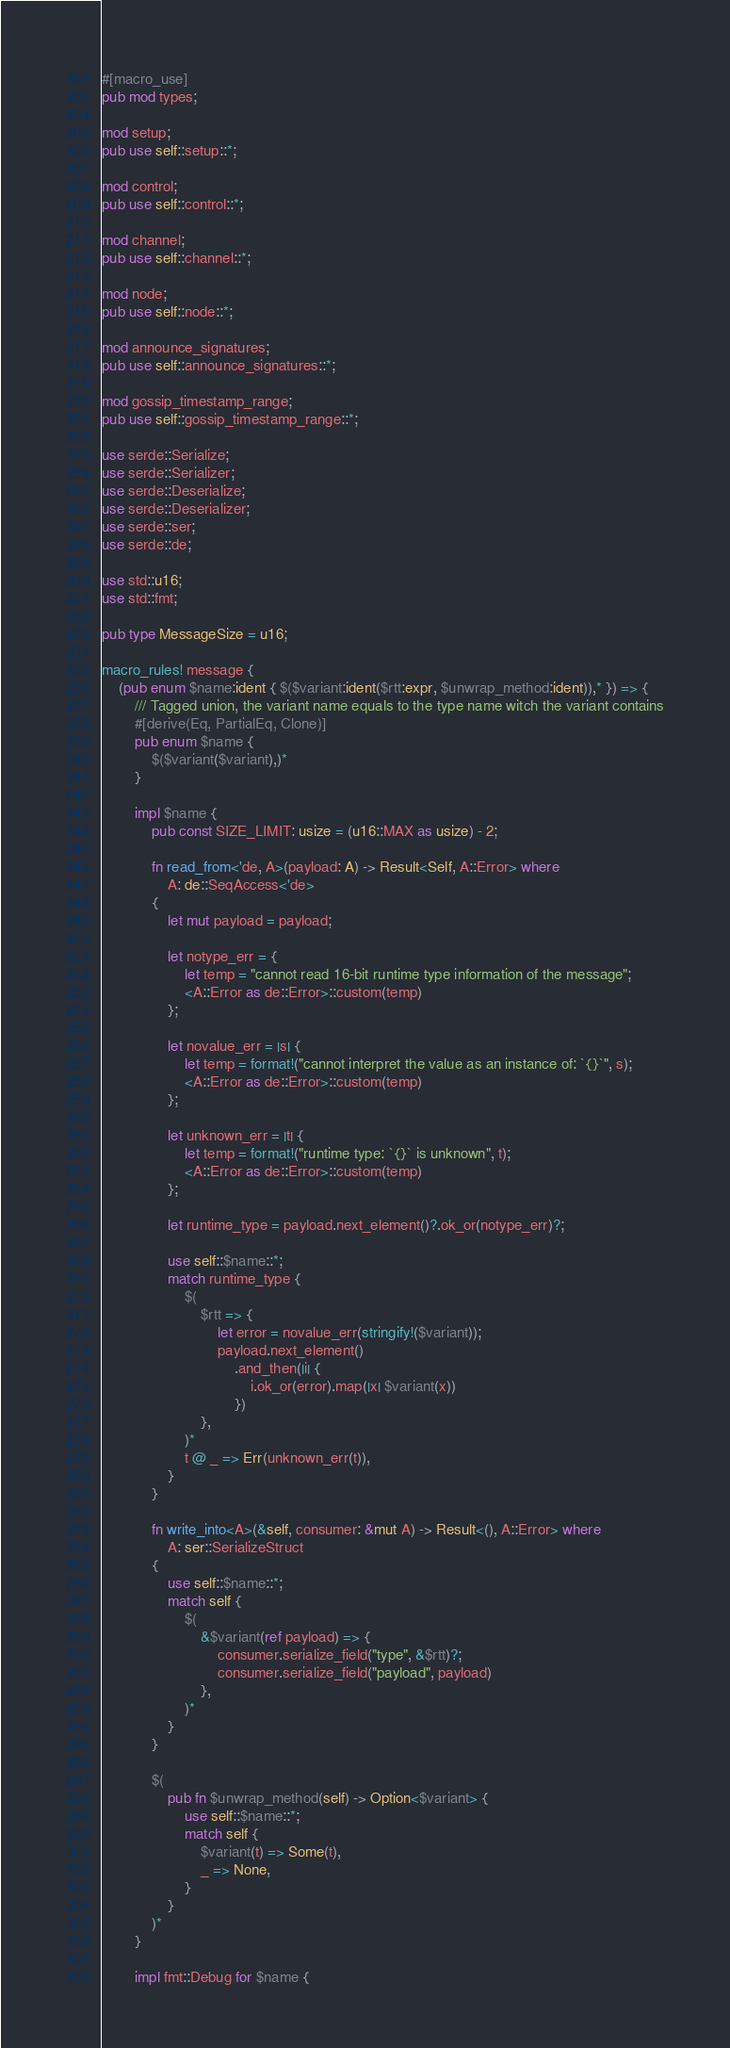<code> <loc_0><loc_0><loc_500><loc_500><_Rust_>#[macro_use]
pub mod types;

mod setup;
pub use self::setup::*;

mod control;
pub use self::control::*;

mod channel;
pub use self::channel::*;

mod node;
pub use self::node::*;

mod announce_signatures;
pub use self::announce_signatures::*;

mod gossip_timestamp_range;
pub use self::gossip_timestamp_range::*;

use serde::Serialize;
use serde::Serializer;
use serde::Deserialize;
use serde::Deserializer;
use serde::ser;
use serde::de;

use std::u16;
use std::fmt;

pub type MessageSize = u16;

macro_rules! message {
    (pub enum $name:ident { $($variant:ident($rtt:expr, $unwrap_method:ident)),* }) => {
        /// Tagged union, the variant name equals to the type name witch the variant contains
        #[derive(Eq, PartialEq, Clone)]
        pub enum $name {
            $($variant($variant),)*
        }

        impl $name {
            pub const SIZE_LIMIT: usize = (u16::MAX as usize) - 2;

            fn read_from<'de, A>(payload: A) -> Result<Self, A::Error> where
                A: de::SeqAccess<'de>
            {
                let mut payload = payload;

                let notype_err = {
                    let temp = "cannot read 16-bit runtime type information of the message";
                    <A::Error as de::Error>::custom(temp)
                };

                let novalue_err = |s| {
                    let temp = format!("cannot interpret the value as an instance of: `{}`", s);
                    <A::Error as de::Error>::custom(temp)
                };

                let unknown_err = |t| {
                    let temp = format!("runtime type: `{}` is unknown", t);
                    <A::Error as de::Error>::custom(temp)
                };

                let runtime_type = payload.next_element()?.ok_or(notype_err)?;

                use self::$name::*;
                match runtime_type {
                    $(
                        $rtt => {
                            let error = novalue_err(stringify!($variant));
                            payload.next_element()
                                .and_then(|i| {
                                    i.ok_or(error).map(|x| $variant(x))
                                })
                        },
                    )*
                    t @ _ => Err(unknown_err(t)),
                }
            }

            fn write_into<A>(&self, consumer: &mut A) -> Result<(), A::Error> where
                A: ser::SerializeStruct
            {
                use self::$name::*;
                match self {
                    $(
                        &$variant(ref payload) => {
                            consumer.serialize_field("type", &$rtt)?;
                            consumer.serialize_field("payload", payload)
                        },
                    )*
                }
            }

            $(
                pub fn $unwrap_method(self) -> Option<$variant> {
                    use self::$name::*;
                    match self {
                        $variant(t) => Some(t),
                        _ => None,
                    }
                }
            )*
        }

        impl fmt::Debug for $name {</code> 